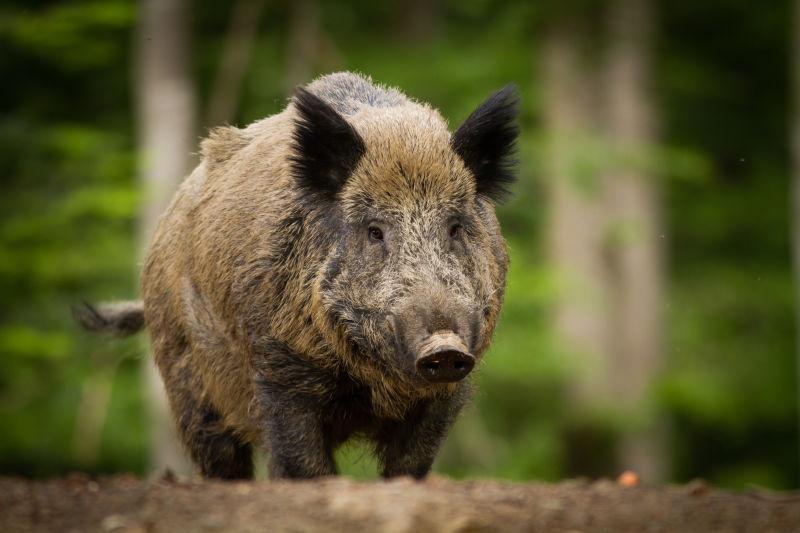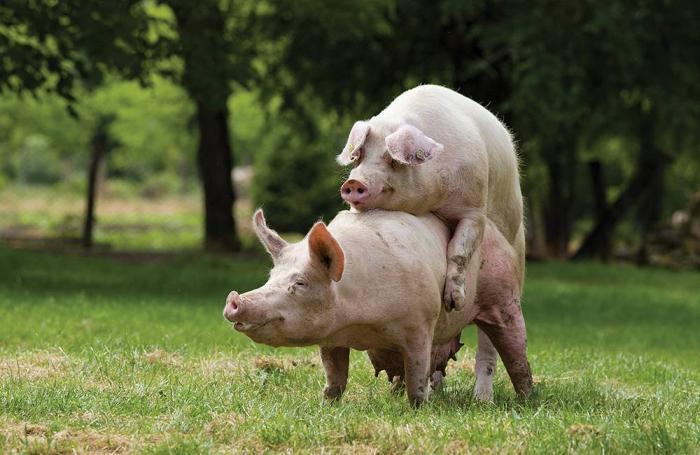The first image is the image on the left, the second image is the image on the right. Considering the images on both sides, is "The combined images contain three pigs, and the right image contains twice as many pigs as the left image." valid? Answer yes or no. Yes. The first image is the image on the left, the second image is the image on the right. Examine the images to the left and right. Is the description "The right image contains exactly two pigs." accurate? Answer yes or no. Yes. 